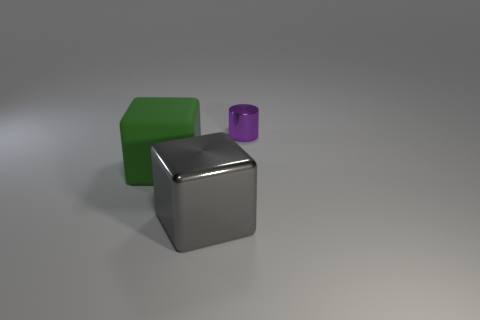Is the color of the rubber block the same as the small object?
Offer a very short reply. No. What number of objects are either purple rubber spheres or metallic things?
Your response must be concise. 2. What size is the green rubber object?
Ensure brevity in your answer.  Large. Is the number of blue cylinders less than the number of tiny purple metallic cylinders?
Your response must be concise. Yes. How many cubes have the same color as the tiny cylinder?
Offer a terse response. 0. There is a metallic thing that is in front of the tiny purple object; does it have the same color as the small thing?
Keep it short and to the point. No. What is the shape of the big thing that is in front of the green cube?
Ensure brevity in your answer.  Cube. Are there any shiny things that are to the left of the object that is to the left of the big metallic cube?
Offer a very short reply. No. What number of tiny purple objects have the same material as the small purple cylinder?
Give a very brief answer. 0. What size is the object in front of the large thing that is behind the metal thing in front of the shiny cylinder?
Your answer should be compact. Large. 